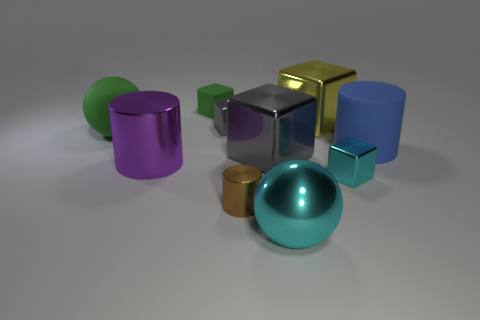How many other objects are the same color as the large rubber sphere?
Offer a very short reply. 1. Is the number of green rubber blocks less than the number of big shiny blocks?
Offer a very short reply. Yes. What is the shape of the green object behind the big ball left of the small gray shiny cube?
Offer a very short reply. Cube. Are there any gray metallic cubes behind the big blue matte cylinder?
Ensure brevity in your answer.  Yes. What is the color of the matte cylinder that is the same size as the yellow cube?
Offer a terse response. Blue. What number of cyan things have the same material as the tiny brown object?
Your answer should be compact. 2. How many other things are the same size as the blue rubber cylinder?
Provide a short and direct response. 5. Is there a red cylinder of the same size as the cyan cube?
Your answer should be compact. No. There is a large metallic sphere right of the tiny brown cylinder; is its color the same as the tiny cylinder?
Your answer should be very brief. No. What number of things are either gray cubes or blue matte balls?
Give a very brief answer. 2. 